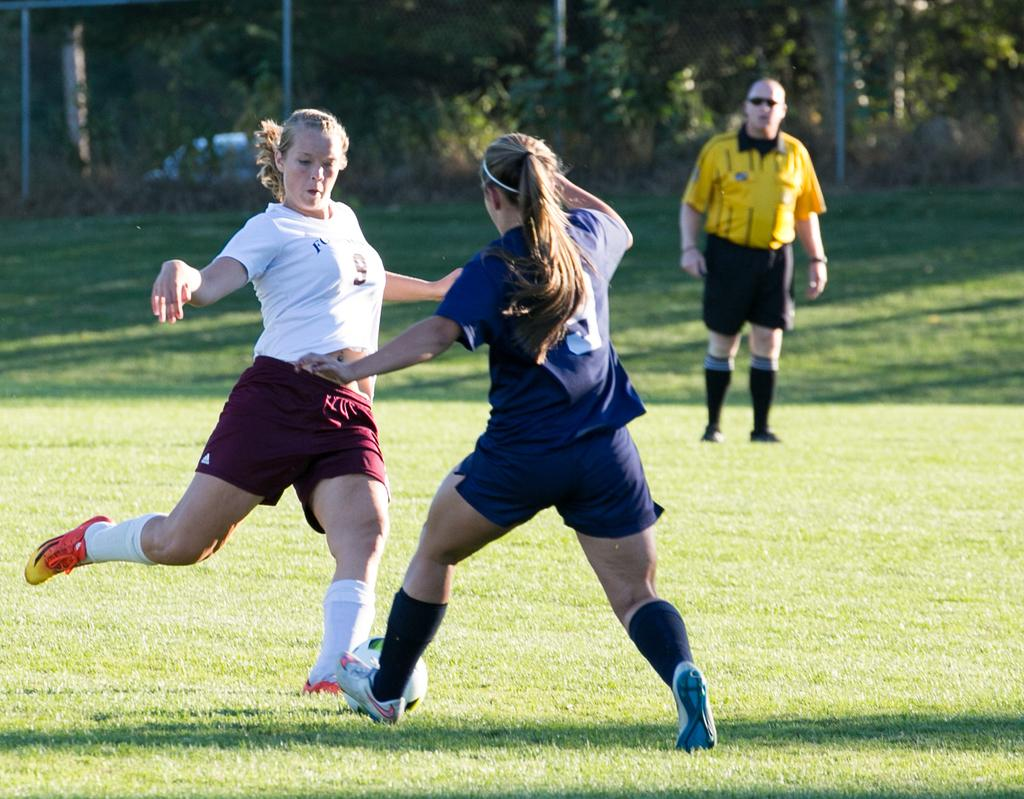What type of activity are the female players engaged in? The female players are running on a ground. Can you describe the gender of the person standing in the image? There is a man standing in the image. What is the setting of the image? The female players are running on a ground. What type of wood is the bee flying around in the image? There is no bee or wood present in the image. 